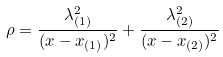Convert formula to latex. <formula><loc_0><loc_0><loc_500><loc_500>\rho = \frac { \lambda _ { ( 1 ) } ^ { 2 } } { ( x - x _ { ( 1 ) } ) ^ { 2 } } + \frac { \lambda _ { ( 2 ) } ^ { 2 } } { ( x - x _ { ( 2 ) } ) ^ { 2 } }</formula> 